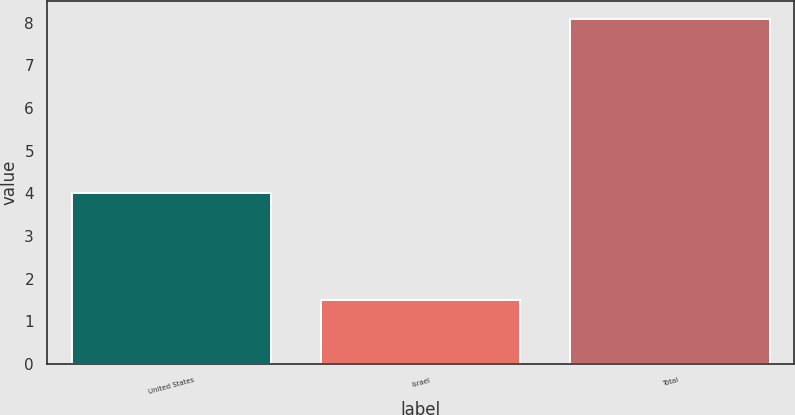<chart> <loc_0><loc_0><loc_500><loc_500><bar_chart><fcel>United States<fcel>Israel<fcel>Total<nl><fcel>4<fcel>1.5<fcel>8.1<nl></chart> 